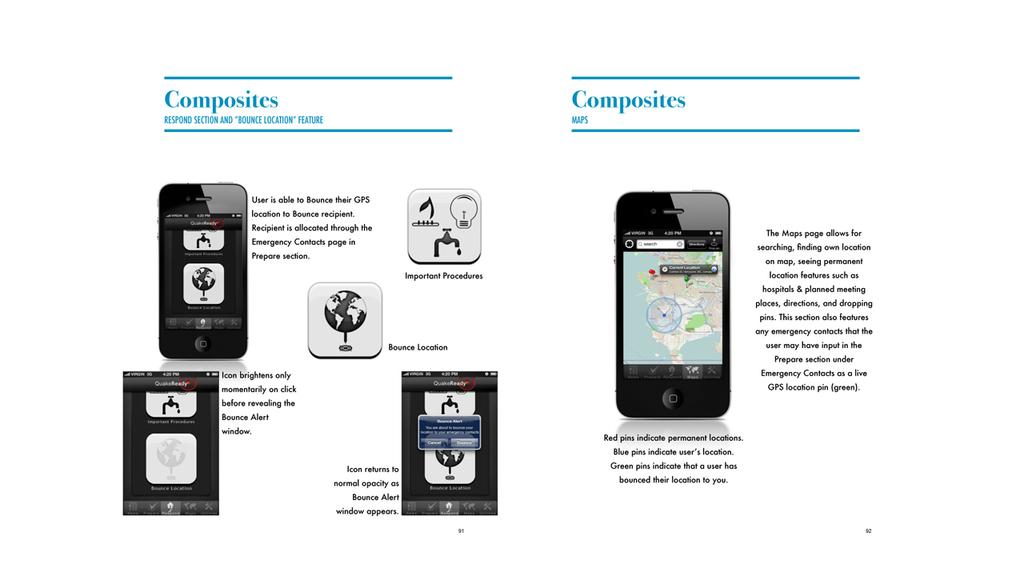<image>
Write a terse but informative summary of the picture. Smartphone that has the wording on top, which says Composites, Respond Section and Bounce Location Feature. 